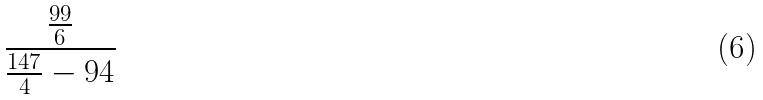Convert formula to latex. <formula><loc_0><loc_0><loc_500><loc_500>\frac { \frac { 9 9 } { 6 } } { \frac { 1 4 7 } { 4 } - 9 4 }</formula> 